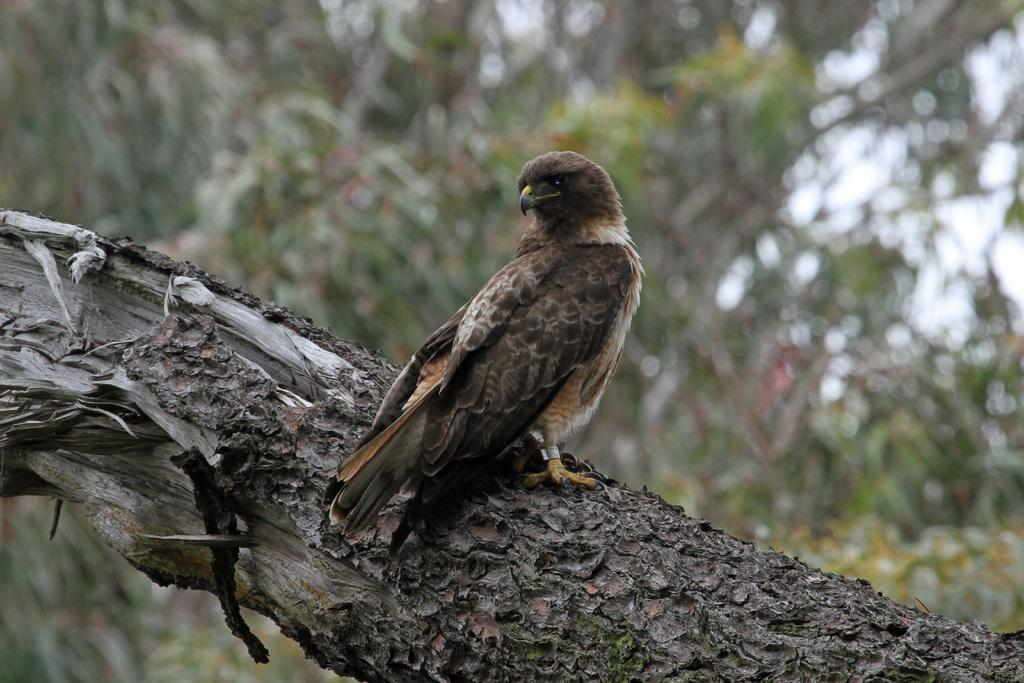What type of animal can be seen in the image? There is a bird in the image. Where is the bird located? The bird is sitting on a branch of a tree. Can you describe the board in the image? The board is in brown and black colors. What can be seen in the background of the image? There are many trees visible in the background. How would you describe the background's appearance? The background is blurry. What type of lunch is the bird eating in the image? There is no lunch present in the image; the bird is sitting on a branch of a tree. 